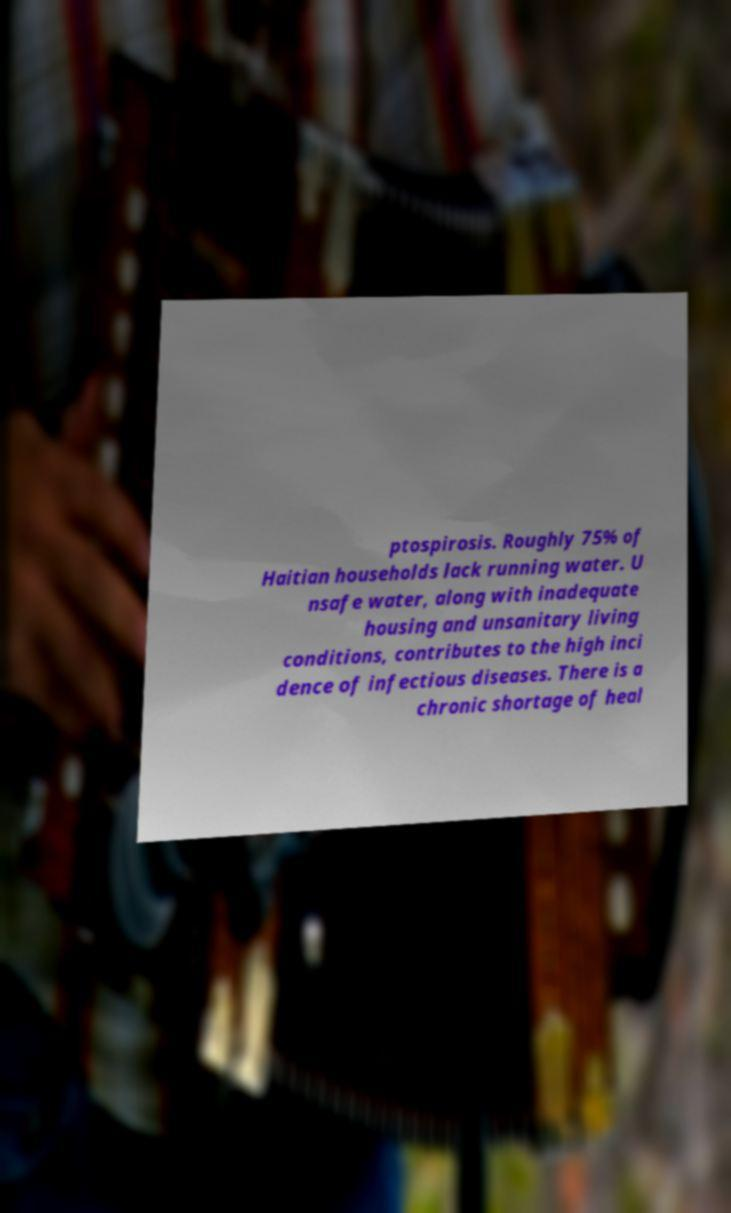There's text embedded in this image that I need extracted. Can you transcribe it verbatim? ptospirosis. Roughly 75% of Haitian households lack running water. U nsafe water, along with inadequate housing and unsanitary living conditions, contributes to the high inci dence of infectious diseases. There is a chronic shortage of heal 